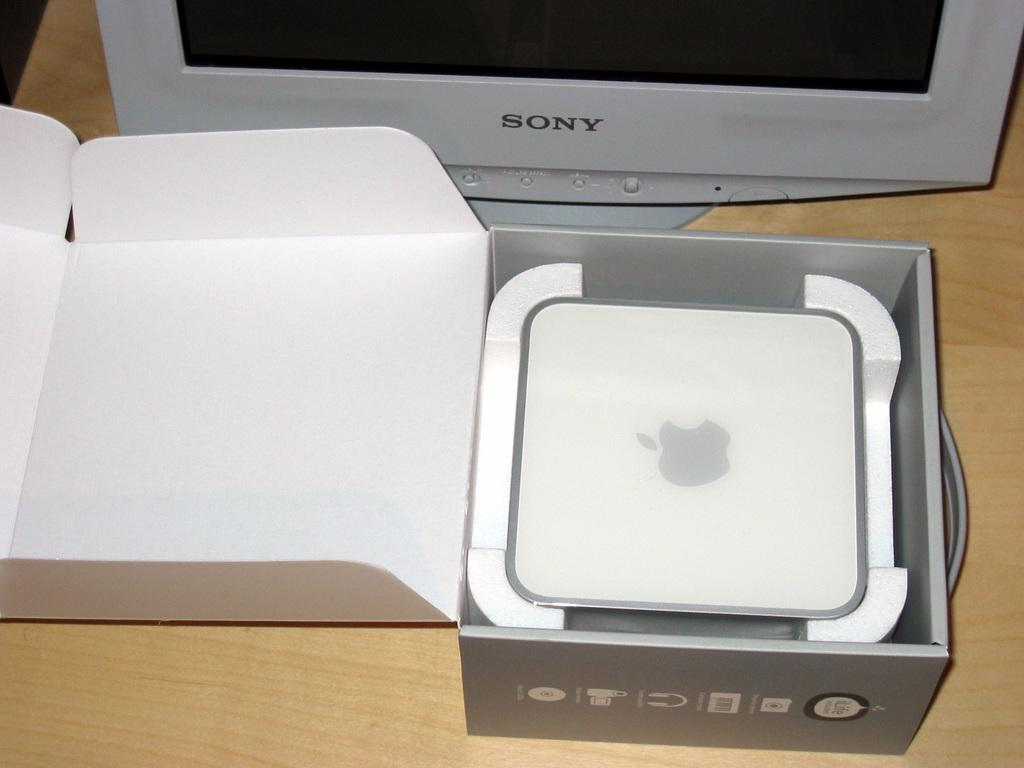What object is present in the image that resembles a container? There is a box in the image. What is inside the box in the image? The box contains an Apple gadget. What type of electronic device might the Apple gadget be? It could be a computer, phone, or tablet, as these are common Apple gadgets. What other electronic device is visible in the image? There is a monitor visible in the image. How many legs can be seen supporting the box in the image? The box does not have legs; it is likely resting on a surface. Can you fold the monitor in the image? The monitor in the image is not a physical object that can be folded; it is a digital display. 